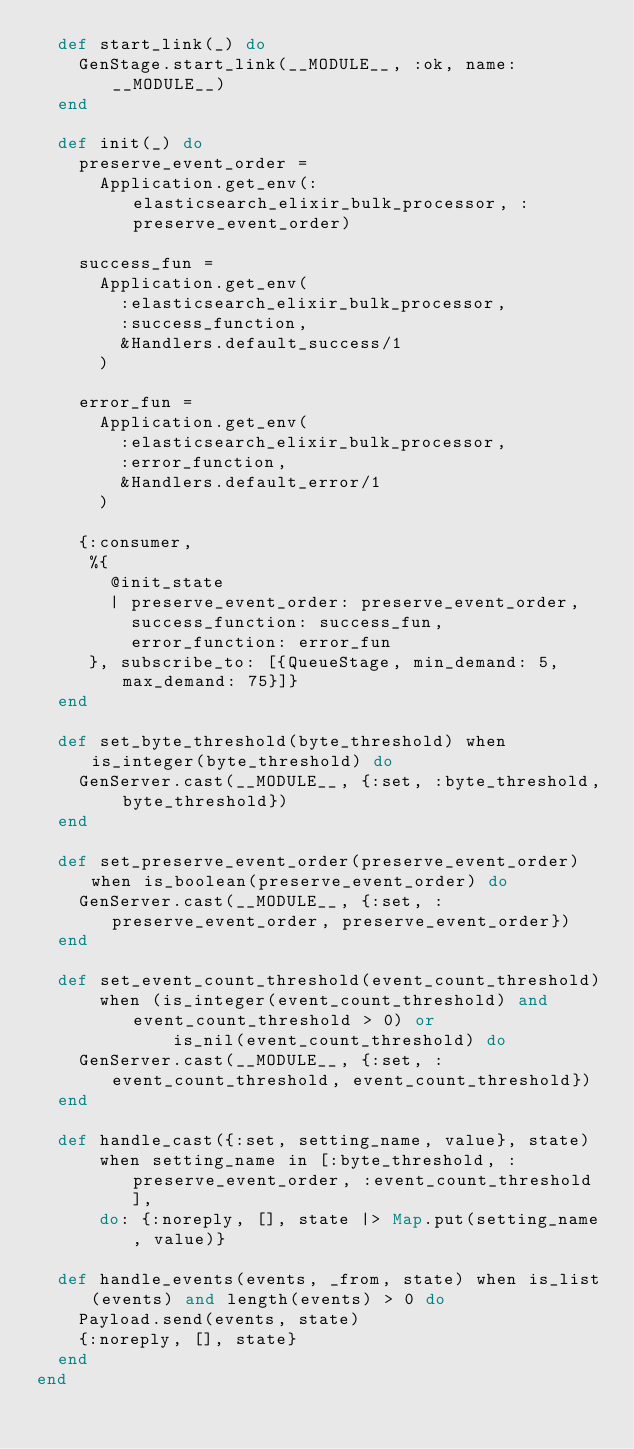Convert code to text. <code><loc_0><loc_0><loc_500><loc_500><_Elixir_>  def start_link(_) do
    GenStage.start_link(__MODULE__, :ok, name: __MODULE__)
  end

  def init(_) do
    preserve_event_order =
      Application.get_env(:elasticsearch_elixir_bulk_processor, :preserve_event_order)

    success_fun =
      Application.get_env(
        :elasticsearch_elixir_bulk_processor,
        :success_function,
        &Handlers.default_success/1
      )

    error_fun =
      Application.get_env(
        :elasticsearch_elixir_bulk_processor,
        :error_function,
        &Handlers.default_error/1
      )

    {:consumer,
     %{
       @init_state
       | preserve_event_order: preserve_event_order,
         success_function: success_fun,
         error_function: error_fun
     }, subscribe_to: [{QueueStage, min_demand: 5, max_demand: 75}]}
  end

  def set_byte_threshold(byte_threshold) when is_integer(byte_threshold) do
    GenServer.cast(__MODULE__, {:set, :byte_threshold, byte_threshold})
  end

  def set_preserve_event_order(preserve_event_order) when is_boolean(preserve_event_order) do
    GenServer.cast(__MODULE__, {:set, :preserve_event_order, preserve_event_order})
  end

  def set_event_count_threshold(event_count_threshold)
      when (is_integer(event_count_threshold) and event_count_threshold > 0) or
             is_nil(event_count_threshold) do
    GenServer.cast(__MODULE__, {:set, :event_count_threshold, event_count_threshold})
  end

  def handle_cast({:set, setting_name, value}, state)
      when setting_name in [:byte_threshold, :preserve_event_order, :event_count_threshold],
      do: {:noreply, [], state |> Map.put(setting_name, value)}

  def handle_events(events, _from, state) when is_list(events) and length(events) > 0 do
    Payload.send(events, state)
    {:noreply, [], state}
  end
end
</code> 